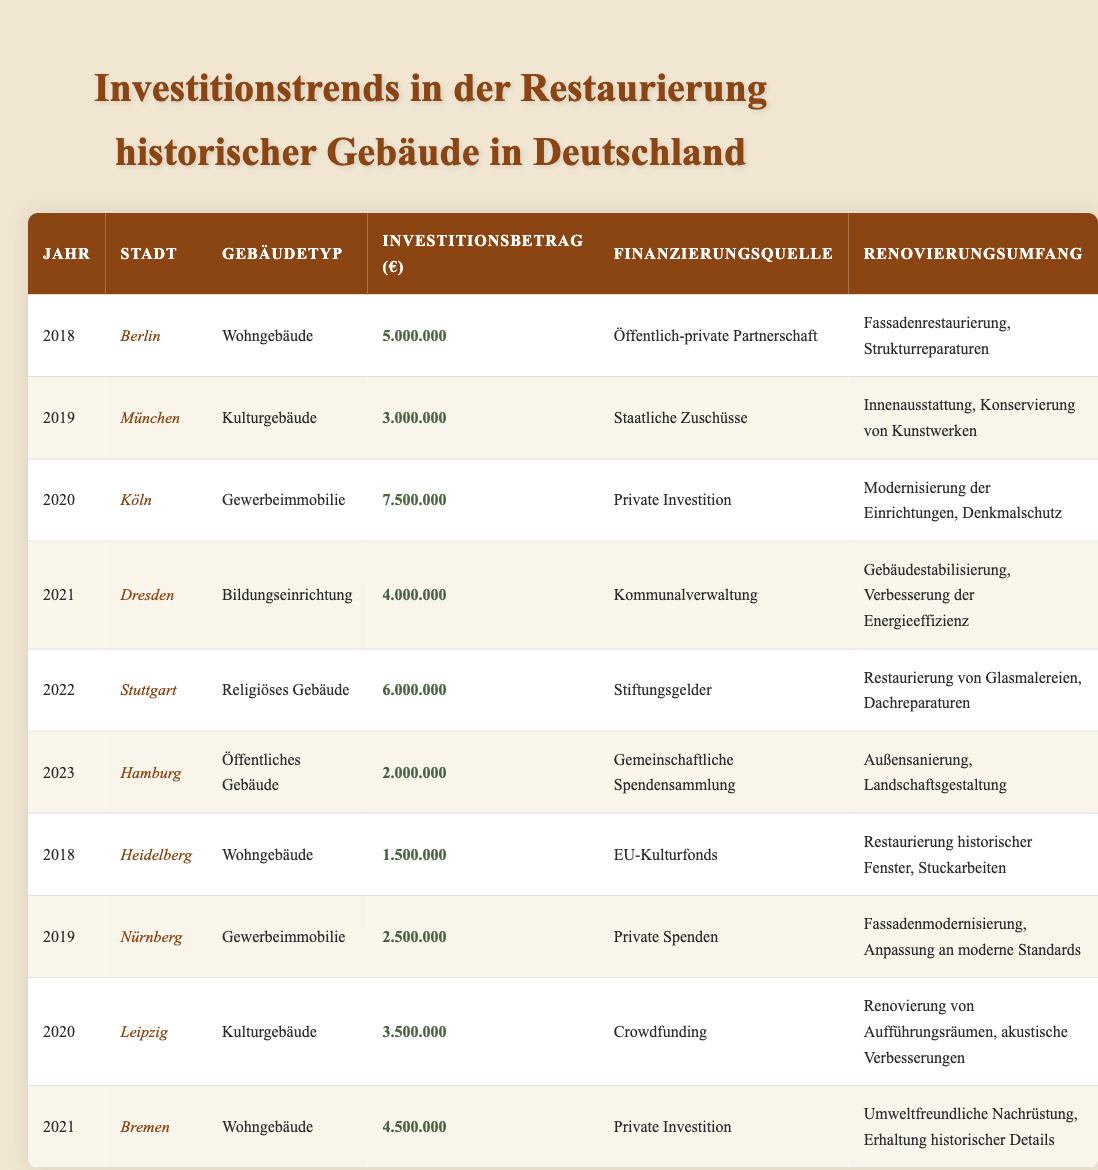What is the total investment amount for renovations in 2020? For the year 2020, the investment amounts are €7,500,000 (Cologne, Commercial), €3,500,000 (Leipzig, Cultural). Adding these amounts gives €7,500,000 + €3,500,000 = €11,000,000.
Answer: €11,000,000 Which city had the highest investment amount in 2021? The investments in 2021 are €4,000,000 (Dresden, Educational) and €4,500,000 (Bremen, Residential). The highest is Bremen at €4,500,000.
Answer: Bremen What is the source of funds for the renovation in Heidelberg in 2018? The source of funds listed for Heidelberg in 2018 is "EU cultural funds".
Answer: EU cultural funds Did any city invest less than €2,500,000 in 2019? In 2019, Munich invested €3,000,000 and Nuremberg invested €2,500,000. Both are not less than €2,500,000, so the answer is no.
Answer: No What is the average investment amount for renovations in residential buildings across all years? The residential investments are €5,000,000 (Berlin, 2018), €1,500,000 (Heidelberg, 2018), and €4,500,000 (Bremen, 2021). The average is calculated as (5,000,000 + 1,500,000 + 4,500,000) / 3 = €3,333,333.
Answer: €3,333,333 Which building type received the most significant investment in 2020 and what was the amount? In 2020, the commercial building type in Cologne received the highest investment at €7,500,000.
Answer: Commercial, €7,500,000 What is the total investment amount for cultural buildings across all years? The cultural buildings' investments are €3,000,000 (Munich, 2019), €3,500,000 (Leipzig, 2020), totaling €6,500,000.
Answer: €6,500,000 Was there any community fundraising involved in restoration projects in 2023? Yes, in 2023, Hamburg's renovation project was funded through community fundraising, as stated in the table.
Answer: Yes How much higher was the investment in religious buildings compared to civic buildings across the recorded years? Stuttgart invested €6,000,000 in religious buildings in 2022, while Hamburg invested €2,000,000 in civic buildings in 2023. The difference is €6,000,000 - €2,000,000 = €4,000,000.
Answer: €4,000,000 In which year did the least amount of investment occur, and what was that amount? Analyzing the investments, the least amount is €1,500,000 in Heidelberg in 2018.
Answer: 2018, €1,500,000 